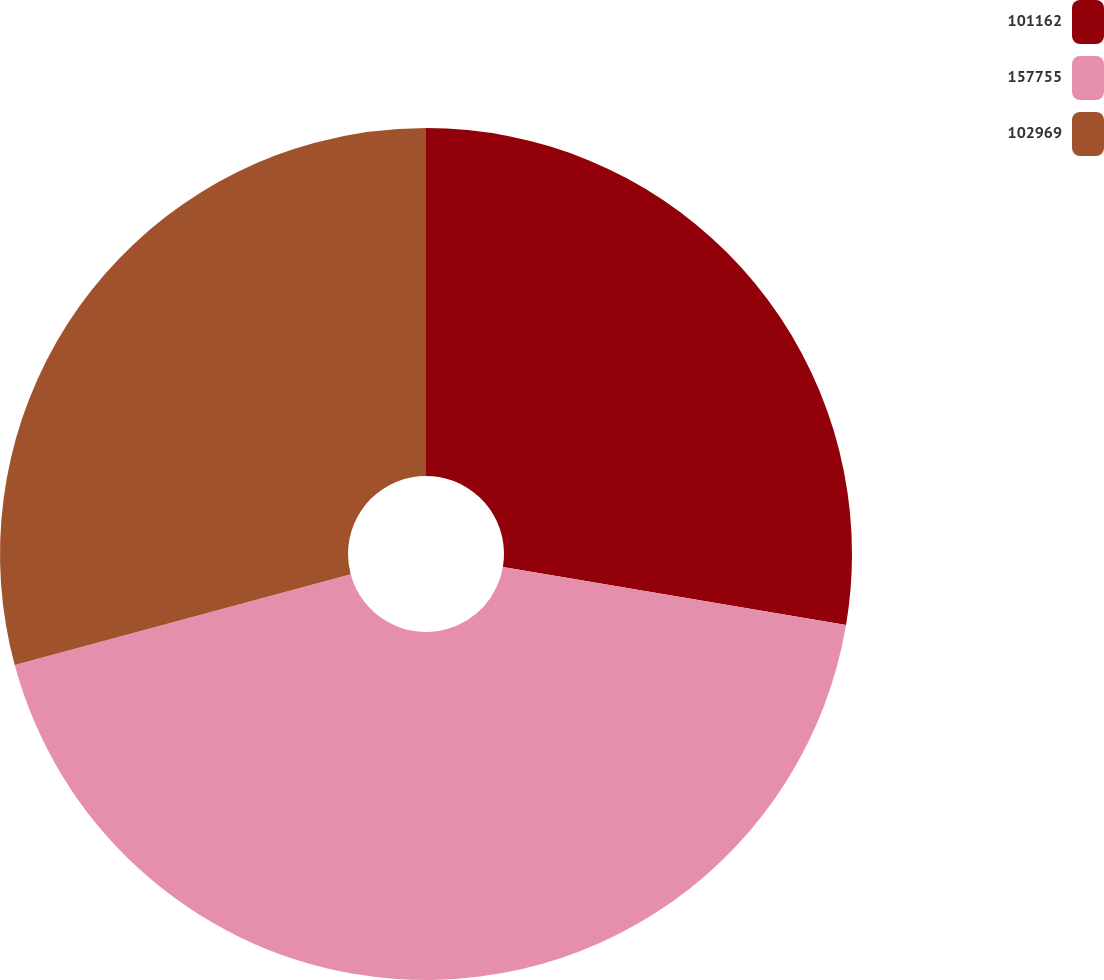Convert chart to OTSL. <chart><loc_0><loc_0><loc_500><loc_500><pie_chart><fcel>101162<fcel>157755<fcel>102969<nl><fcel>27.67%<fcel>43.14%<fcel>29.2%<nl></chart> 